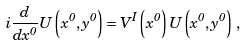Convert formula to latex. <formula><loc_0><loc_0><loc_500><loc_500>i \frac { d } { d x ^ { 0 } } U \left ( x ^ { 0 } , y ^ { 0 } \right ) = V ^ { I } \left ( x ^ { 0 } \right ) U \left ( x ^ { 0 } , y ^ { 0 } \right ) \, ,</formula> 